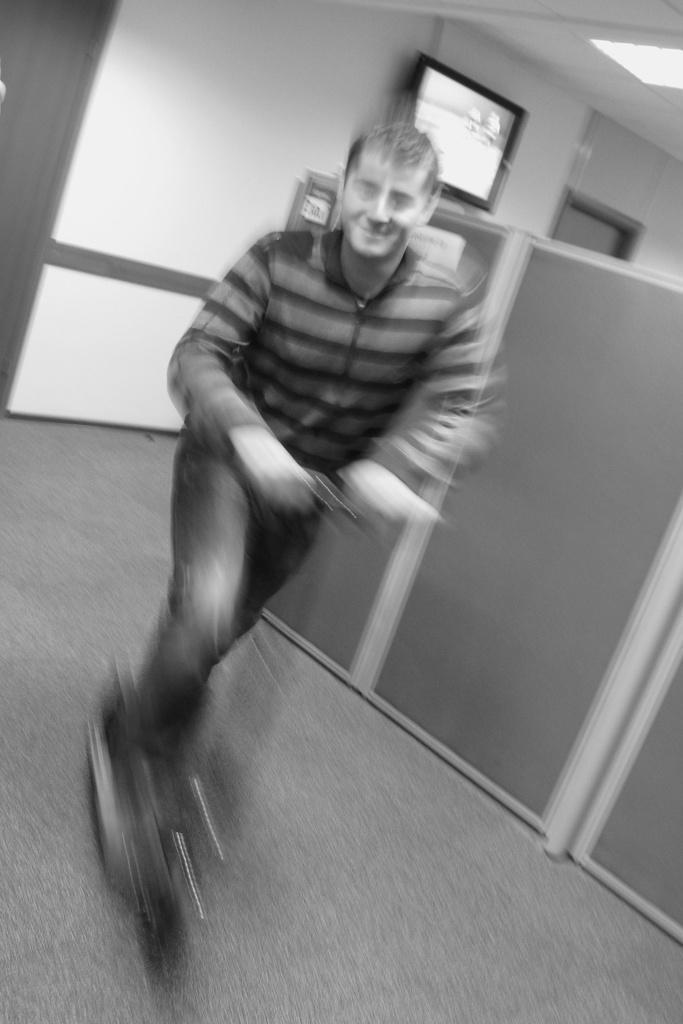How would you summarize this image in a sentence or two? This is a black and white image. I think this picture is slightly blurred. I can see a person riding the three wheeler scooter. This looks like a board. I can see a television, which is attached to the wall. This is a floor. On the right side of the image, I can see a ceiling light, which is attached to a ceiling. 